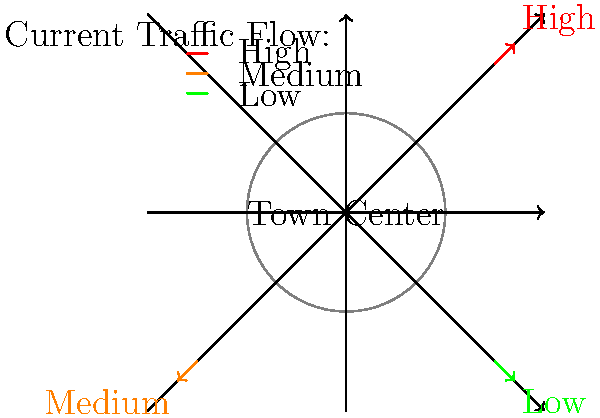Based on the current traffic flow patterns shown in the diagram of Reading town center, which road layout modification would be most effective in reducing congestion while maintaining easy access for local residents and families visiting the town center? To determine the optimal road layout for reducing traffic congestion in Reading town center, we need to analyze the current traffic flow patterns and consider the needs of local residents and families. Let's follow these steps:

1. Analyze current traffic flow:
   - High traffic flow is observed on the diagonal road from top-right to bottom-left
   - Medium traffic flow is seen on the diagonal road from top-left to bottom-right
   - Low traffic flow is present on the horizontal and vertical roads

2. Consider local resident and family needs:
   - Easy access to the town center is important
   - Pedestrian-friendly areas would benefit families

3. Evaluate potential solutions:
   a) Implement a one-way system:
      - Convert high-traffic diagonal road to one-way (inbound)
      - Convert medium-traffic diagonal road to one-way (outbound)
      - This would reduce conflicting traffic movements

   b) Create a ring road:
      - Develop a circular road around the town center
      - Divert through-traffic away from the center
      - Provide access points for local residents and visitors

   c) Pedestrianize the town center:
      - Close the central area to vehicles
      - Create pedestrian-only zones for families
      - Implement park-and-ride facilities on the outskirts

4. Assess the best solution:
   The ring road concept (option b) appears to be the most effective because:
   - It addresses high traffic flow by providing an alternative route
   - It maintains access for local residents and families
   - It allows for the creation of pedestrian-friendly areas within the center
   - It can be combined with park-and-ride facilities for improved accessibility

5. Implementation considerations:
   - Design multiple access points to the town center from the ring road
   - Incorporate cycling lanes and pedestrian crossings for safety
   - Include clear signage for easy navigation
   - Plan for public transport integration with the new layout

By implementing a ring road system with these considerations, Reading can effectively reduce traffic congestion in the town center while maintaining accessibility for local residents and creating a more family-friendly environment.
Answer: Implement a ring road system around the town center with multiple access points. 